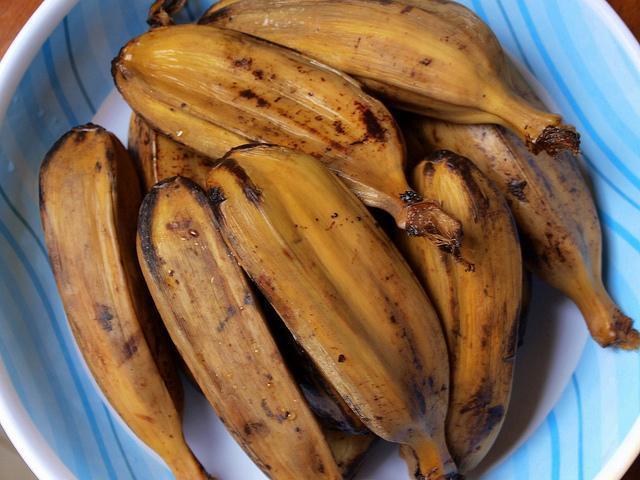How many plantains are visible?
Give a very brief answer. 8. How many bananas can be seen?
Give a very brief answer. 8. 